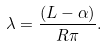Convert formula to latex. <formula><loc_0><loc_0><loc_500><loc_500>\lambda = \frac { ( L - \alpha ) } { R \pi } .</formula> 